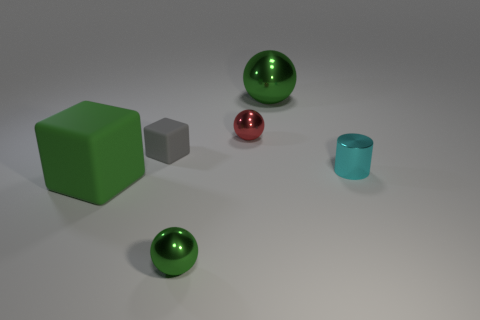There is a green thing that is made of the same material as the tiny green sphere; what shape is it?
Keep it short and to the point. Sphere. Is the gray block made of the same material as the tiny cyan cylinder?
Ensure brevity in your answer.  No. Are there fewer small cubes left of the small cylinder than tiny metallic things that are in front of the gray block?
Offer a very short reply. Yes. The other sphere that is the same color as the big ball is what size?
Your answer should be compact. Small. How many big blocks are in front of the tiny matte thing that is on the left side of the tiny thing that is in front of the big green cube?
Offer a terse response. 1. Is the color of the large ball the same as the large rubber thing?
Give a very brief answer. Yes. Is there a small ball that has the same color as the large shiny object?
Your answer should be compact. Yes. What color is the cylinder that is the same size as the red shiny object?
Ensure brevity in your answer.  Cyan. Is there a tiny cyan metallic object that has the same shape as the large green metallic object?
Offer a very short reply. No. There is a small metal object that is the same color as the big block; what shape is it?
Offer a terse response. Sphere. 